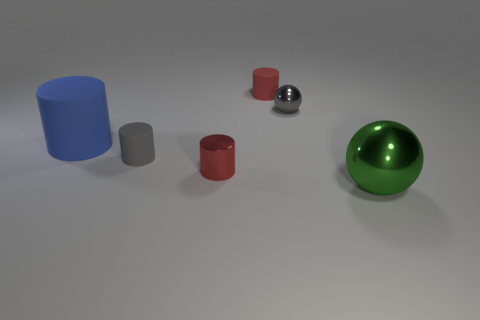How many other objects are the same color as the big sphere?
Provide a succinct answer. 0. What number of cyan things are either large rubber cylinders or metallic cylinders?
Offer a terse response. 0. What is the size of the gray shiny ball?
Ensure brevity in your answer.  Small. How many metallic objects are green things or small red things?
Your answer should be very brief. 2. Is the number of blue cylinders less than the number of small green cubes?
Offer a very short reply. No. How many other objects are the same material as the green object?
Provide a short and direct response. 2. The other gray object that is the same shape as the big metal object is what size?
Your answer should be very brief. Small. Is the material of the ball in front of the red metal cylinder the same as the big thing on the left side of the tiny sphere?
Ensure brevity in your answer.  No. Is the number of big blue matte cylinders in front of the big cylinder less than the number of small metallic things?
Your answer should be compact. Yes. Are there any other things that have the same shape as the blue matte thing?
Your response must be concise. Yes. 